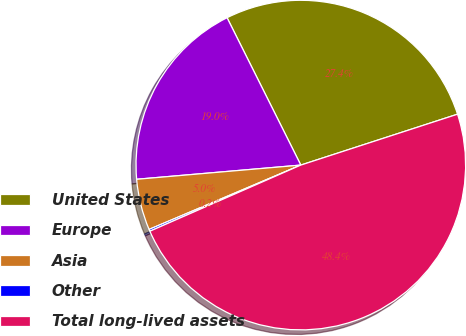Convert chart to OTSL. <chart><loc_0><loc_0><loc_500><loc_500><pie_chart><fcel>United States<fcel>Europe<fcel>Asia<fcel>Other<fcel>Total long-lived assets<nl><fcel>27.39%<fcel>18.99%<fcel>5.01%<fcel>0.19%<fcel>48.43%<nl></chart> 